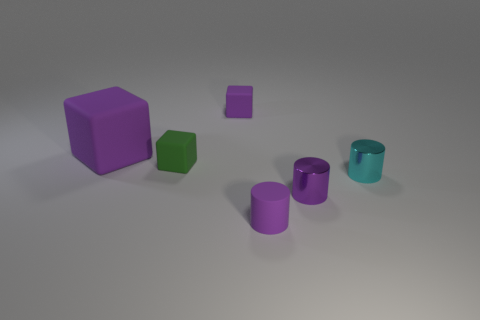How many other things are the same size as the cyan shiny thing?
Offer a terse response. 4. Do the large purple cube to the left of the tiny green rubber thing and the small block that is behind the green object have the same material?
Make the answer very short. Yes. There is a purple rubber object left of the tiny purple object left of the purple matte cylinder; what size is it?
Your response must be concise. Large. Is there a big cube of the same color as the small rubber cylinder?
Give a very brief answer. Yes. There is a tiny matte object in front of the small cyan metal thing; does it have the same color as the large matte object that is behind the small green rubber object?
Offer a terse response. Yes. What is the shape of the tiny green matte thing?
Offer a very short reply. Cube. What number of small purple objects are behind the cyan metal object?
Provide a short and direct response. 1. How many cyan objects have the same material as the big purple thing?
Offer a terse response. 0. Do the purple object that is to the right of the small rubber cylinder and the tiny green block have the same material?
Make the answer very short. No. Are there any big matte spheres?
Offer a terse response. No. 